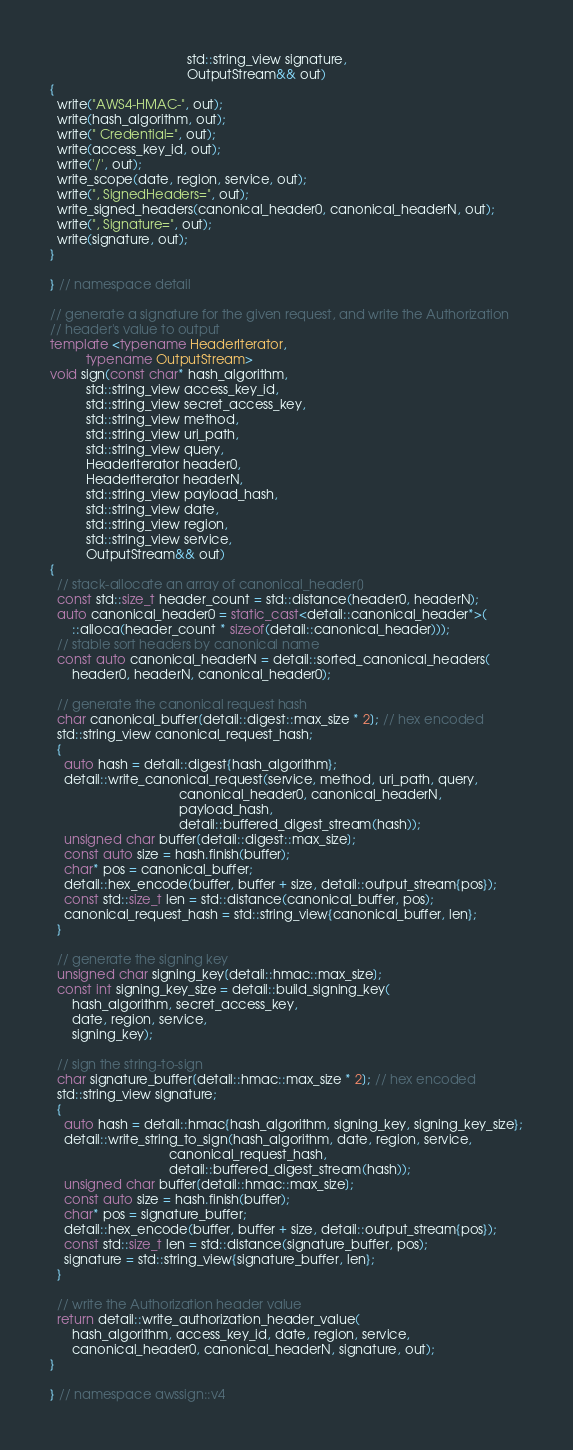<code> <loc_0><loc_0><loc_500><loc_500><_C++_>                                      std::string_view signature,
                                      OutputStream&& out)
{
  write("AWS4-HMAC-", out);
  write(hash_algorithm, out);
  write(" Credential=", out);
  write(access_key_id, out);
  write('/', out);
  write_scope(date, region, service, out);
  write(", SignedHeaders=", out);
  write_signed_headers(canonical_header0, canonical_headerN, out);
  write(", Signature=", out);
  write(signature, out);
}

} // namespace detail

// generate a signature for the given request, and write the Authorization
// header's value to output
template <typename HeaderIterator,
          typename OutputStream>
void sign(const char* hash_algorithm,
          std::string_view access_key_id,
          std::string_view secret_access_key,
          std::string_view method,
          std::string_view uri_path,
          std::string_view query,
          HeaderIterator header0,
          HeaderIterator headerN,
          std::string_view payload_hash,
          std::string_view date,
          std::string_view region,
          std::string_view service,
          OutputStream&& out)
{
  // stack-allocate an array of canonical_header[]
  const std::size_t header_count = std::distance(header0, headerN);
  auto canonical_header0 = static_cast<detail::canonical_header*>(
      ::alloca(header_count * sizeof(detail::canonical_header)));
  // stable sort headers by canonical name
  const auto canonical_headerN = detail::sorted_canonical_headers(
      header0, headerN, canonical_header0);

  // generate the canonical request hash
  char canonical_buffer[detail::digest::max_size * 2]; // hex encoded
  std::string_view canonical_request_hash;
  {
    auto hash = detail::digest{hash_algorithm};
    detail::write_canonical_request(service, method, uri_path, query,
                                    canonical_header0, canonical_headerN,
                                    payload_hash,
                                    detail::buffered_digest_stream(hash));
    unsigned char buffer[detail::digest::max_size];
    const auto size = hash.finish(buffer);
    char* pos = canonical_buffer;
    detail::hex_encode(buffer, buffer + size, detail::output_stream{pos});
    const std::size_t len = std::distance(canonical_buffer, pos);
    canonical_request_hash = std::string_view{canonical_buffer, len};
  }

  // generate the signing key
  unsigned char signing_key[detail::hmac::max_size];
  const int signing_key_size = detail::build_signing_key(
      hash_algorithm, secret_access_key,
      date, region, service,
      signing_key);

  // sign the string-to-sign
  char signature_buffer[detail::hmac::max_size * 2]; // hex encoded
  std::string_view signature;
  {
    auto hash = detail::hmac{hash_algorithm, signing_key, signing_key_size};
    detail::write_string_to_sign(hash_algorithm, date, region, service,
                                 canonical_request_hash,
                                 detail::buffered_digest_stream(hash));
    unsigned char buffer[detail::hmac::max_size];
    const auto size = hash.finish(buffer);
    char* pos = signature_buffer;
    detail::hex_encode(buffer, buffer + size, detail::output_stream{pos});
    const std::size_t len = std::distance(signature_buffer, pos);
    signature = std::string_view{signature_buffer, len};
  }

  // write the Authorization header value
  return detail::write_authorization_header_value(
      hash_algorithm, access_key_id, date, region, service,
      canonical_header0, canonical_headerN, signature, out);
}

} // namespace awssign::v4
</code> 